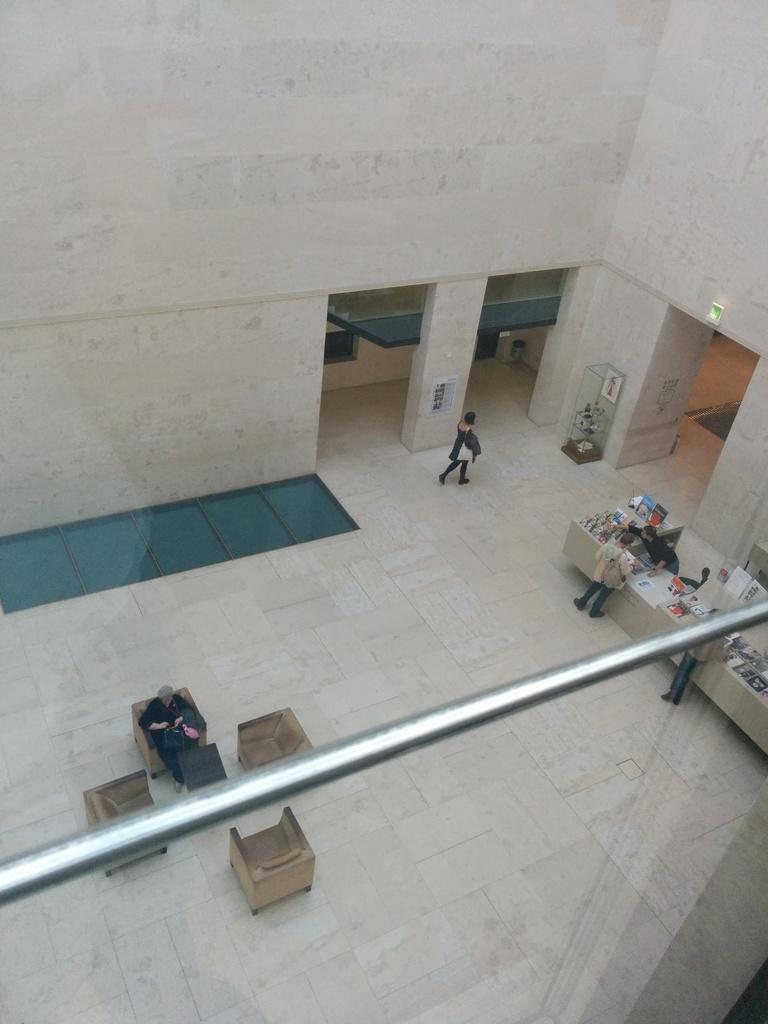In one or two sentences, can you explain what this image depicts? In this image I can see few chairs and table. Person is sitting on the chair. I can see few people standing and holding a bags and few objects on the table. The wall is in white color. I can see a flower pot. 